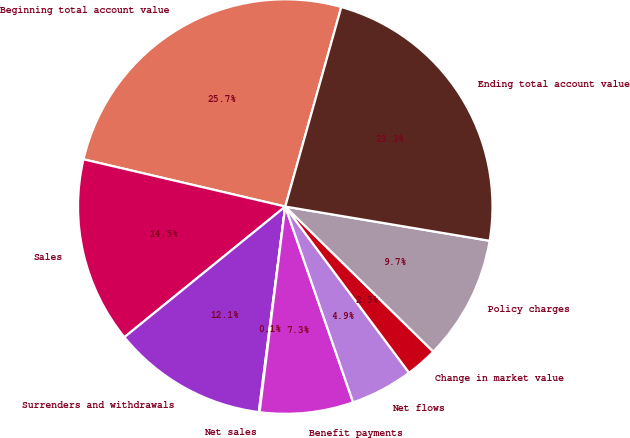Convert chart. <chart><loc_0><loc_0><loc_500><loc_500><pie_chart><fcel>Beginning total account value<fcel>Sales<fcel>Surrenders and withdrawals<fcel>Net sales<fcel>Benefit payments<fcel>Net flows<fcel>Change in market value<fcel>Policy charges<fcel>Ending total account value<nl><fcel>25.7%<fcel>14.52%<fcel>12.11%<fcel>0.06%<fcel>7.29%<fcel>4.88%<fcel>2.47%<fcel>9.7%<fcel>23.29%<nl></chart> 